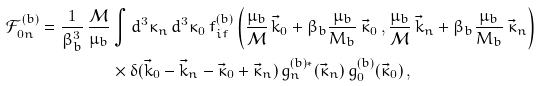Convert formula to latex. <formula><loc_0><loc_0><loc_500><loc_500>\mathcal { F } _ { 0 n } ^ { ( b ) } = \frac { 1 } { \beta _ { b } ^ { 3 } } \, \frac { \mathcal { M } } { \mu _ { b } } & \int d ^ { 3 } \kappa _ { n } \, d ^ { 3 } \kappa _ { 0 } \, f _ { i f } ^ { ( b ) } \left ( \frac { \mu _ { b } } { \mathcal { M } } \, \vec { k } _ { 0 } + \beta _ { b } \frac { \mu _ { b } } { M _ { b } } \, \vec { \kappa } _ { 0 } \, , \frac { \mu _ { b } } { \mathcal { M } } \, \vec { k } _ { n } + \beta _ { b } \frac { \mu _ { b } } { M _ { b } } \, \vec { \kappa } _ { n } \right ) \\ & \times \delta ( \vec { k } _ { 0 } - \vec { k } _ { n } - \vec { \kappa } _ { 0 } + \vec { \kappa } _ { n } ) \, g _ { n } ^ { ( b ) * } ( \vec { \kappa } _ { n } ) \, g _ { 0 } ^ { ( b ) } ( \vec { \kappa } _ { 0 } ) \, ,</formula> 